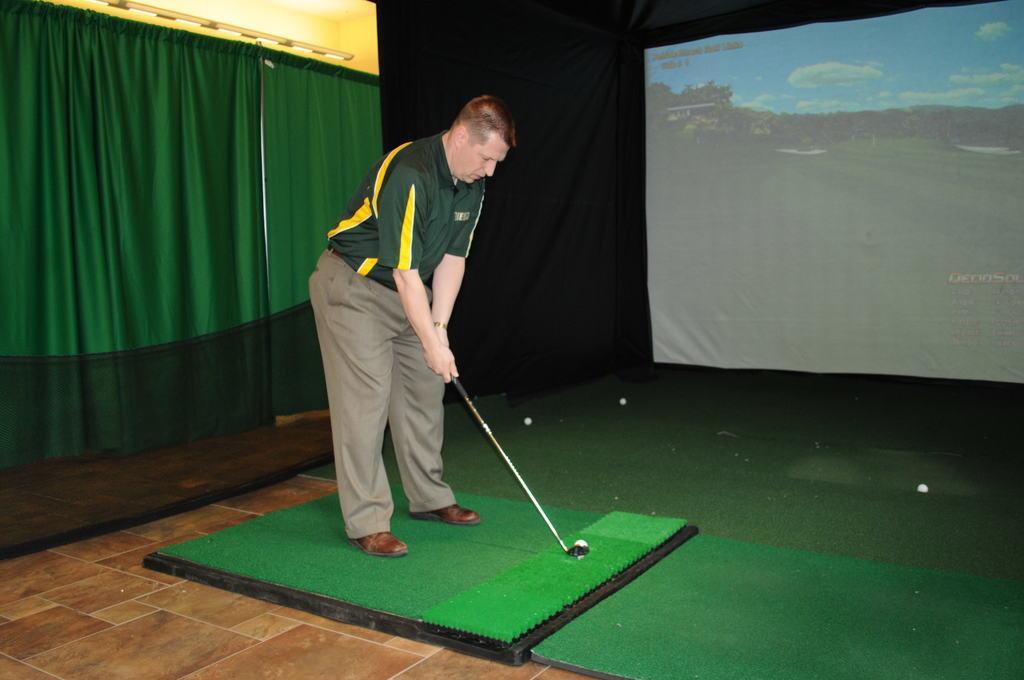Please provide a concise description of this image. In this image we can see a person holding an object. There are few balls in the image. We can see a screen at the right side of the image. There are few curtains at the left side of the image. There are few lights at the left top most of the image. On the screen we can see a grassy land, many trees and few clouds in the sky. 